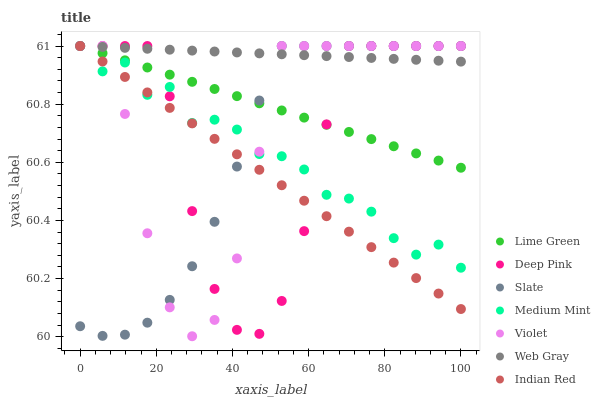Does Indian Red have the minimum area under the curve?
Answer yes or no. Yes. Does Web Gray have the maximum area under the curve?
Answer yes or no. Yes. Does Deep Pink have the minimum area under the curve?
Answer yes or no. No. Does Deep Pink have the maximum area under the curve?
Answer yes or no. No. Is Web Gray the smoothest?
Answer yes or no. Yes. Is Violet the roughest?
Answer yes or no. Yes. Is Deep Pink the smoothest?
Answer yes or no. No. Is Deep Pink the roughest?
Answer yes or no. No. Does Violet have the lowest value?
Answer yes or no. Yes. Does Deep Pink have the lowest value?
Answer yes or no. No. Does Lime Green have the highest value?
Answer yes or no. Yes. Does Deep Pink intersect Medium Mint?
Answer yes or no. Yes. Is Deep Pink less than Medium Mint?
Answer yes or no. No. Is Deep Pink greater than Medium Mint?
Answer yes or no. No. 